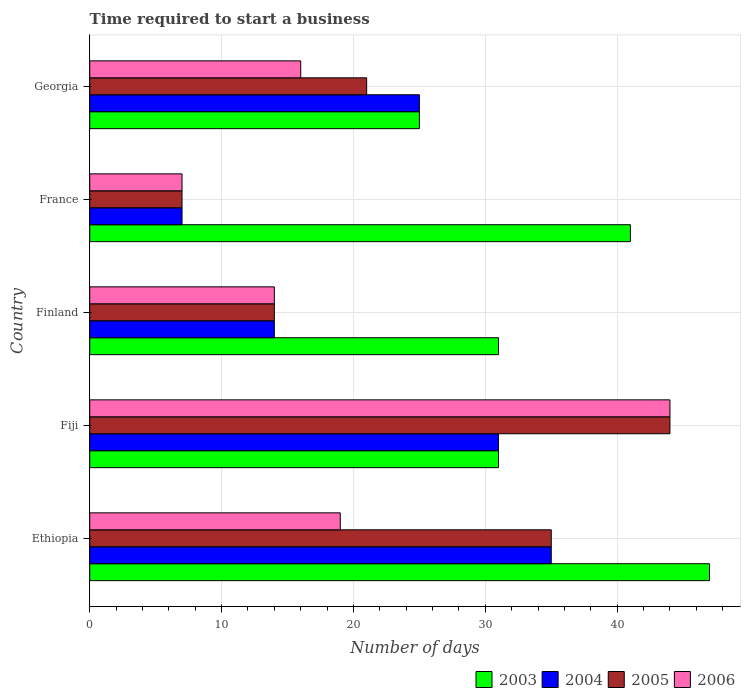How many different coloured bars are there?
Provide a short and direct response. 4. How many groups of bars are there?
Keep it short and to the point. 5. Are the number of bars on each tick of the Y-axis equal?
Ensure brevity in your answer.  Yes. How many bars are there on the 1st tick from the top?
Ensure brevity in your answer.  4. What is the label of the 1st group of bars from the top?
Give a very brief answer. Georgia. In how many cases, is the number of bars for a given country not equal to the number of legend labels?
Your answer should be compact. 0. What is the number of days required to start a business in 2005 in Fiji?
Make the answer very short. 44. In which country was the number of days required to start a business in 2003 maximum?
Offer a very short reply. Ethiopia. What is the total number of days required to start a business in 2004 in the graph?
Make the answer very short. 112. What is the difference between the number of days required to start a business in 2006 in Ethiopia and that in Finland?
Your answer should be compact. 5. What is the average number of days required to start a business in 2003 per country?
Give a very brief answer. 35. What is the ratio of the number of days required to start a business in 2004 in Fiji to that in Finland?
Provide a short and direct response. 2.21. Is the number of days required to start a business in 2005 in Finland less than that in Georgia?
Your answer should be compact. Yes. Is the difference between the number of days required to start a business in 2004 in Ethiopia and Fiji greater than the difference between the number of days required to start a business in 2003 in Ethiopia and Fiji?
Keep it short and to the point. No. What is the difference between the highest and the second highest number of days required to start a business in 2005?
Your response must be concise. 9. What is the difference between the highest and the lowest number of days required to start a business in 2004?
Give a very brief answer. 28. In how many countries, is the number of days required to start a business in 2003 greater than the average number of days required to start a business in 2003 taken over all countries?
Your answer should be very brief. 2. Is it the case that in every country, the sum of the number of days required to start a business in 2005 and number of days required to start a business in 2006 is greater than the sum of number of days required to start a business in 2004 and number of days required to start a business in 2003?
Offer a terse response. No. What does the 4th bar from the top in France represents?
Give a very brief answer. 2003. What does the 1st bar from the bottom in Finland represents?
Your response must be concise. 2003. Is it the case that in every country, the sum of the number of days required to start a business in 2005 and number of days required to start a business in 2004 is greater than the number of days required to start a business in 2006?
Provide a succinct answer. Yes. How many bars are there?
Give a very brief answer. 20. How many countries are there in the graph?
Ensure brevity in your answer.  5. Does the graph contain any zero values?
Keep it short and to the point. No. Where does the legend appear in the graph?
Your answer should be compact. Bottom right. How many legend labels are there?
Offer a very short reply. 4. How are the legend labels stacked?
Keep it short and to the point. Horizontal. What is the title of the graph?
Give a very brief answer. Time required to start a business. Does "2011" appear as one of the legend labels in the graph?
Give a very brief answer. No. What is the label or title of the X-axis?
Your answer should be very brief. Number of days. What is the Number of days in 2003 in Ethiopia?
Keep it short and to the point. 47. What is the Number of days of 2005 in Ethiopia?
Keep it short and to the point. 35. What is the Number of days in 2003 in Fiji?
Your response must be concise. 31. What is the Number of days of 2004 in Fiji?
Offer a terse response. 31. What is the Number of days of 2005 in Fiji?
Provide a succinct answer. 44. What is the Number of days in 2006 in Fiji?
Make the answer very short. 44. What is the Number of days of 2003 in Finland?
Your response must be concise. 31. What is the Number of days of 2004 in Finland?
Ensure brevity in your answer.  14. What is the Number of days in 2005 in Finland?
Give a very brief answer. 14. What is the Number of days in 2006 in Finland?
Provide a succinct answer. 14. What is the Number of days of 2004 in France?
Your answer should be compact. 7. What is the Number of days of 2005 in France?
Your answer should be compact. 7. What is the Number of days in 2003 in Georgia?
Keep it short and to the point. 25. What is the Number of days of 2005 in Georgia?
Your answer should be compact. 21. What is the Number of days of 2006 in Georgia?
Make the answer very short. 16. Across all countries, what is the maximum Number of days of 2003?
Your response must be concise. 47. Across all countries, what is the maximum Number of days of 2004?
Offer a very short reply. 35. Across all countries, what is the maximum Number of days of 2005?
Keep it short and to the point. 44. Across all countries, what is the maximum Number of days of 2006?
Give a very brief answer. 44. Across all countries, what is the minimum Number of days of 2005?
Your response must be concise. 7. What is the total Number of days in 2003 in the graph?
Your answer should be compact. 175. What is the total Number of days in 2004 in the graph?
Your answer should be compact. 112. What is the total Number of days in 2005 in the graph?
Offer a very short reply. 121. What is the difference between the Number of days of 2003 in Ethiopia and that in Fiji?
Ensure brevity in your answer.  16. What is the difference between the Number of days in 2004 in Ethiopia and that in Fiji?
Your response must be concise. 4. What is the difference between the Number of days in 2005 in Ethiopia and that in Fiji?
Your answer should be very brief. -9. What is the difference between the Number of days in 2006 in Ethiopia and that in Fiji?
Keep it short and to the point. -25. What is the difference between the Number of days of 2003 in Ethiopia and that in France?
Ensure brevity in your answer.  6. What is the difference between the Number of days in 2004 in Ethiopia and that in France?
Ensure brevity in your answer.  28. What is the difference between the Number of days of 2005 in Ethiopia and that in France?
Give a very brief answer. 28. What is the difference between the Number of days in 2006 in Ethiopia and that in France?
Offer a terse response. 12. What is the difference between the Number of days of 2003 in Ethiopia and that in Georgia?
Keep it short and to the point. 22. What is the difference between the Number of days of 2006 in Ethiopia and that in Georgia?
Ensure brevity in your answer.  3. What is the difference between the Number of days in 2003 in Fiji and that in Finland?
Keep it short and to the point. 0. What is the difference between the Number of days of 2004 in Fiji and that in Finland?
Offer a very short reply. 17. What is the difference between the Number of days in 2006 in Fiji and that in Finland?
Offer a very short reply. 30. What is the difference between the Number of days of 2003 in Fiji and that in France?
Give a very brief answer. -10. What is the difference between the Number of days in 2004 in Fiji and that in France?
Provide a short and direct response. 24. What is the difference between the Number of days of 2003 in Fiji and that in Georgia?
Ensure brevity in your answer.  6. What is the difference between the Number of days of 2004 in Fiji and that in Georgia?
Your answer should be compact. 6. What is the difference between the Number of days of 2006 in Fiji and that in Georgia?
Give a very brief answer. 28. What is the difference between the Number of days in 2004 in Finland and that in France?
Your answer should be compact. 7. What is the difference between the Number of days of 2003 in Finland and that in Georgia?
Ensure brevity in your answer.  6. What is the difference between the Number of days in 2004 in Finland and that in Georgia?
Make the answer very short. -11. What is the difference between the Number of days of 2005 in Finland and that in Georgia?
Your answer should be compact. -7. What is the difference between the Number of days in 2005 in France and that in Georgia?
Provide a short and direct response. -14. What is the difference between the Number of days of 2006 in France and that in Georgia?
Your answer should be compact. -9. What is the difference between the Number of days in 2003 in Ethiopia and the Number of days in 2004 in Fiji?
Your answer should be very brief. 16. What is the difference between the Number of days of 2003 in Ethiopia and the Number of days of 2006 in Fiji?
Your answer should be very brief. 3. What is the difference between the Number of days of 2004 in Ethiopia and the Number of days of 2006 in Fiji?
Offer a very short reply. -9. What is the difference between the Number of days of 2005 in Ethiopia and the Number of days of 2006 in Fiji?
Keep it short and to the point. -9. What is the difference between the Number of days of 2003 in Ethiopia and the Number of days of 2004 in Finland?
Ensure brevity in your answer.  33. What is the difference between the Number of days in 2003 in Ethiopia and the Number of days in 2005 in Finland?
Your answer should be very brief. 33. What is the difference between the Number of days in 2005 in Ethiopia and the Number of days in 2006 in Finland?
Provide a short and direct response. 21. What is the difference between the Number of days in 2003 in Ethiopia and the Number of days in 2004 in France?
Provide a short and direct response. 40. What is the difference between the Number of days of 2003 in Ethiopia and the Number of days of 2006 in France?
Provide a succinct answer. 40. What is the difference between the Number of days of 2004 in Ethiopia and the Number of days of 2006 in France?
Your answer should be compact. 28. What is the difference between the Number of days of 2003 in Ethiopia and the Number of days of 2004 in Georgia?
Provide a short and direct response. 22. What is the difference between the Number of days in 2003 in Ethiopia and the Number of days in 2006 in Georgia?
Offer a very short reply. 31. What is the difference between the Number of days of 2004 in Ethiopia and the Number of days of 2006 in Georgia?
Your response must be concise. 19. What is the difference between the Number of days in 2003 in Fiji and the Number of days in 2005 in Finland?
Make the answer very short. 17. What is the difference between the Number of days in 2004 in Fiji and the Number of days in 2005 in Finland?
Offer a terse response. 17. What is the difference between the Number of days in 2004 in Fiji and the Number of days in 2006 in Finland?
Offer a very short reply. 17. What is the difference between the Number of days of 2003 in Fiji and the Number of days of 2004 in France?
Provide a short and direct response. 24. What is the difference between the Number of days in 2003 in Fiji and the Number of days in 2005 in France?
Keep it short and to the point. 24. What is the difference between the Number of days in 2005 in Fiji and the Number of days in 2006 in France?
Make the answer very short. 37. What is the difference between the Number of days in 2003 in Fiji and the Number of days in 2006 in Georgia?
Offer a very short reply. 15. What is the difference between the Number of days in 2004 in Fiji and the Number of days in 2005 in Georgia?
Provide a short and direct response. 10. What is the difference between the Number of days in 2003 in Finland and the Number of days in 2004 in France?
Your answer should be compact. 24. What is the difference between the Number of days in 2003 in Finland and the Number of days in 2005 in France?
Give a very brief answer. 24. What is the difference between the Number of days of 2003 in Finland and the Number of days of 2006 in France?
Give a very brief answer. 24. What is the difference between the Number of days in 2004 in Finland and the Number of days in 2005 in France?
Make the answer very short. 7. What is the difference between the Number of days in 2005 in Finland and the Number of days in 2006 in France?
Keep it short and to the point. 7. What is the difference between the Number of days of 2003 in Finland and the Number of days of 2004 in Georgia?
Provide a succinct answer. 6. What is the difference between the Number of days in 2003 in Finland and the Number of days in 2005 in Georgia?
Your answer should be very brief. 10. What is the difference between the Number of days of 2005 in Finland and the Number of days of 2006 in Georgia?
Give a very brief answer. -2. What is the difference between the Number of days in 2003 in France and the Number of days in 2004 in Georgia?
Keep it short and to the point. 16. What is the difference between the Number of days of 2003 in France and the Number of days of 2005 in Georgia?
Your response must be concise. 20. What is the difference between the Number of days in 2003 in France and the Number of days in 2006 in Georgia?
Provide a succinct answer. 25. What is the difference between the Number of days of 2004 in France and the Number of days of 2005 in Georgia?
Your response must be concise. -14. What is the average Number of days of 2004 per country?
Offer a terse response. 22.4. What is the average Number of days of 2005 per country?
Your answer should be very brief. 24.2. What is the difference between the Number of days of 2003 and Number of days of 2004 in Ethiopia?
Offer a very short reply. 12. What is the difference between the Number of days of 2003 and Number of days of 2005 in Ethiopia?
Your answer should be compact. 12. What is the difference between the Number of days in 2004 and Number of days in 2005 in Ethiopia?
Make the answer very short. 0. What is the difference between the Number of days in 2005 and Number of days in 2006 in Ethiopia?
Provide a short and direct response. 16. What is the difference between the Number of days in 2003 and Number of days in 2004 in Finland?
Keep it short and to the point. 17. What is the difference between the Number of days in 2004 and Number of days in 2005 in Finland?
Your answer should be very brief. 0. What is the difference between the Number of days in 2004 and Number of days in 2006 in Finland?
Keep it short and to the point. 0. What is the difference between the Number of days in 2003 and Number of days in 2004 in France?
Keep it short and to the point. 34. What is the difference between the Number of days of 2003 and Number of days of 2005 in France?
Your answer should be compact. 34. What is the difference between the Number of days in 2004 and Number of days in 2005 in France?
Provide a short and direct response. 0. What is the difference between the Number of days in 2004 and Number of days in 2006 in France?
Offer a terse response. 0. What is the difference between the Number of days in 2005 and Number of days in 2006 in France?
Keep it short and to the point. 0. What is the difference between the Number of days of 2003 and Number of days of 2005 in Georgia?
Provide a short and direct response. 4. What is the difference between the Number of days of 2003 and Number of days of 2006 in Georgia?
Offer a terse response. 9. What is the difference between the Number of days of 2004 and Number of days of 2005 in Georgia?
Make the answer very short. 4. What is the difference between the Number of days of 2005 and Number of days of 2006 in Georgia?
Provide a succinct answer. 5. What is the ratio of the Number of days in 2003 in Ethiopia to that in Fiji?
Make the answer very short. 1.52. What is the ratio of the Number of days of 2004 in Ethiopia to that in Fiji?
Ensure brevity in your answer.  1.13. What is the ratio of the Number of days in 2005 in Ethiopia to that in Fiji?
Ensure brevity in your answer.  0.8. What is the ratio of the Number of days in 2006 in Ethiopia to that in Fiji?
Make the answer very short. 0.43. What is the ratio of the Number of days of 2003 in Ethiopia to that in Finland?
Give a very brief answer. 1.52. What is the ratio of the Number of days of 2004 in Ethiopia to that in Finland?
Offer a terse response. 2.5. What is the ratio of the Number of days in 2005 in Ethiopia to that in Finland?
Offer a very short reply. 2.5. What is the ratio of the Number of days in 2006 in Ethiopia to that in Finland?
Provide a succinct answer. 1.36. What is the ratio of the Number of days of 2003 in Ethiopia to that in France?
Offer a terse response. 1.15. What is the ratio of the Number of days in 2005 in Ethiopia to that in France?
Offer a terse response. 5. What is the ratio of the Number of days in 2006 in Ethiopia to that in France?
Your answer should be very brief. 2.71. What is the ratio of the Number of days of 2003 in Ethiopia to that in Georgia?
Your answer should be very brief. 1.88. What is the ratio of the Number of days of 2004 in Ethiopia to that in Georgia?
Provide a succinct answer. 1.4. What is the ratio of the Number of days of 2005 in Ethiopia to that in Georgia?
Offer a terse response. 1.67. What is the ratio of the Number of days in 2006 in Ethiopia to that in Georgia?
Your answer should be very brief. 1.19. What is the ratio of the Number of days of 2003 in Fiji to that in Finland?
Keep it short and to the point. 1. What is the ratio of the Number of days in 2004 in Fiji to that in Finland?
Ensure brevity in your answer.  2.21. What is the ratio of the Number of days of 2005 in Fiji to that in Finland?
Your answer should be compact. 3.14. What is the ratio of the Number of days of 2006 in Fiji to that in Finland?
Give a very brief answer. 3.14. What is the ratio of the Number of days in 2003 in Fiji to that in France?
Keep it short and to the point. 0.76. What is the ratio of the Number of days of 2004 in Fiji to that in France?
Offer a terse response. 4.43. What is the ratio of the Number of days in 2005 in Fiji to that in France?
Provide a short and direct response. 6.29. What is the ratio of the Number of days in 2006 in Fiji to that in France?
Provide a succinct answer. 6.29. What is the ratio of the Number of days of 2003 in Fiji to that in Georgia?
Make the answer very short. 1.24. What is the ratio of the Number of days in 2004 in Fiji to that in Georgia?
Provide a succinct answer. 1.24. What is the ratio of the Number of days in 2005 in Fiji to that in Georgia?
Keep it short and to the point. 2.1. What is the ratio of the Number of days of 2006 in Fiji to that in Georgia?
Offer a terse response. 2.75. What is the ratio of the Number of days of 2003 in Finland to that in France?
Your response must be concise. 0.76. What is the ratio of the Number of days in 2004 in Finland to that in France?
Your answer should be very brief. 2. What is the ratio of the Number of days of 2005 in Finland to that in France?
Give a very brief answer. 2. What is the ratio of the Number of days in 2006 in Finland to that in France?
Your response must be concise. 2. What is the ratio of the Number of days of 2003 in Finland to that in Georgia?
Offer a terse response. 1.24. What is the ratio of the Number of days of 2004 in Finland to that in Georgia?
Provide a short and direct response. 0.56. What is the ratio of the Number of days of 2006 in Finland to that in Georgia?
Your answer should be compact. 0.88. What is the ratio of the Number of days in 2003 in France to that in Georgia?
Keep it short and to the point. 1.64. What is the ratio of the Number of days of 2004 in France to that in Georgia?
Give a very brief answer. 0.28. What is the ratio of the Number of days in 2005 in France to that in Georgia?
Give a very brief answer. 0.33. What is the ratio of the Number of days of 2006 in France to that in Georgia?
Provide a short and direct response. 0.44. What is the difference between the highest and the second highest Number of days in 2003?
Your answer should be very brief. 6. What is the difference between the highest and the second highest Number of days in 2006?
Your answer should be very brief. 25. What is the difference between the highest and the lowest Number of days of 2004?
Your response must be concise. 28. What is the difference between the highest and the lowest Number of days in 2005?
Provide a short and direct response. 37. 